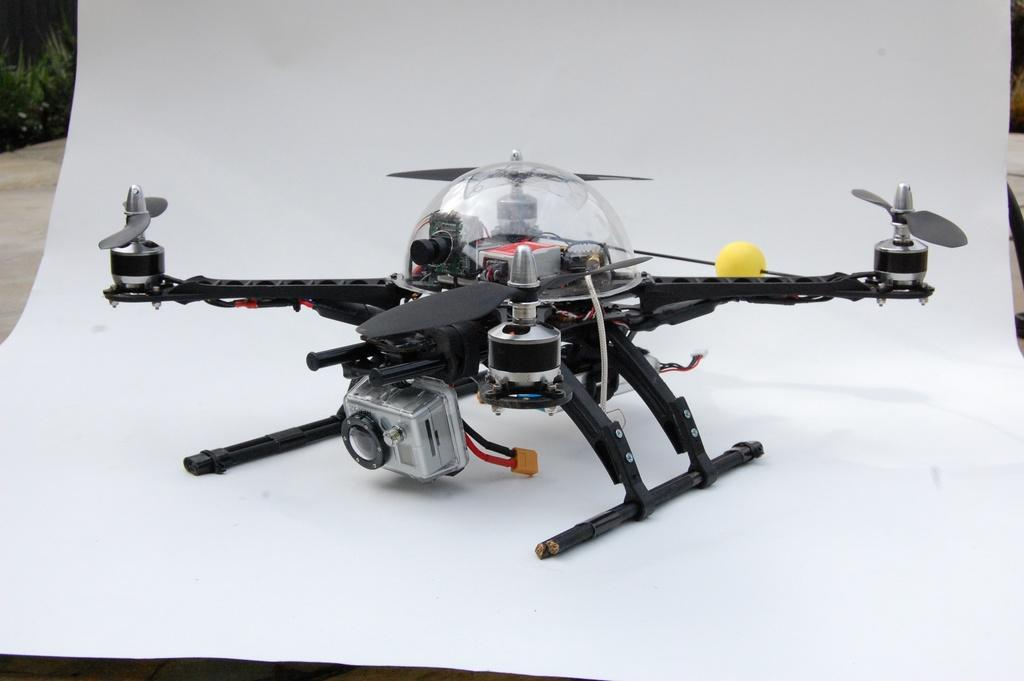What is the main subject of the image? The main subject of the image is a chart. What is depicted on the chart? The chart features a drone. Can you describe any other elements in the image? There are objects visible in the background of the image. What type of engine can be seen in the image? There is no engine present in the image; it features a chart with a drone. Can you tell me how many drains are visible in the image? There are no drains present in the image; it features a chart with a drone and objects in the background. 